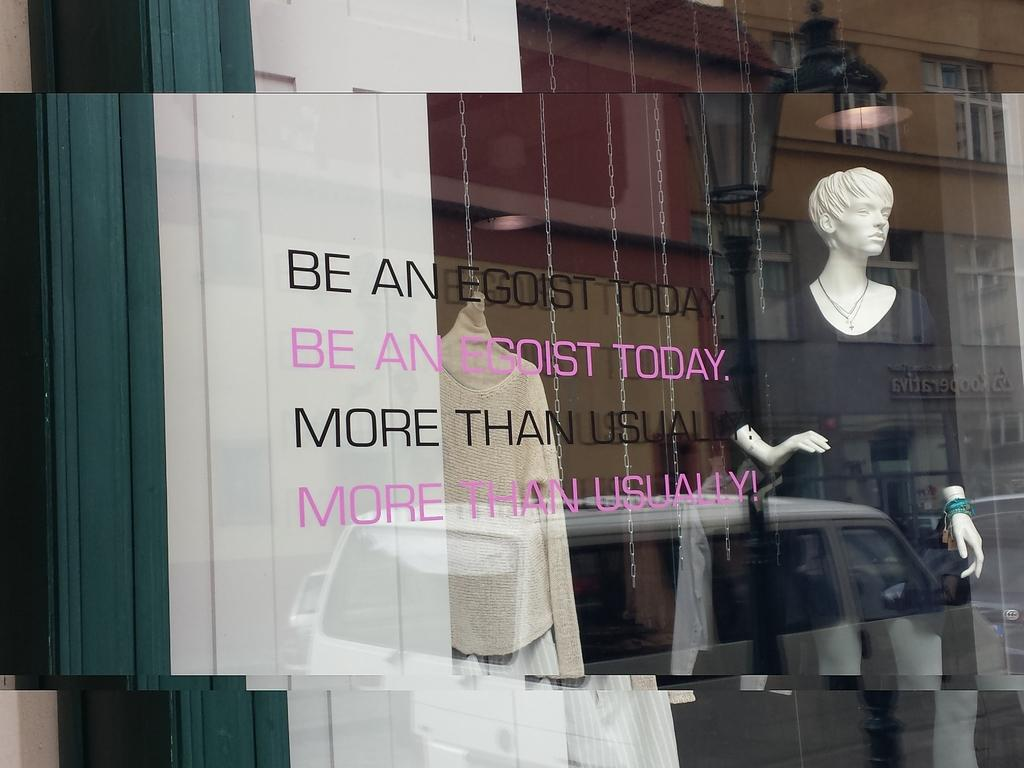What type of objects can be seen in the image? There are mannequins in the image. What else can be seen in the image besides the mannequins? There are reflections of buildings, light poles, and vehicles visible in the image. Where are these reflections visible? These reflections are visible on the glass. Is there any text on the glass? Yes, there is some text on the glass. How many spiders are crawling on the mannequins in the image? There are no spiders visible on the mannequins in the image. What type of knife is being used by the mannequins in the image? There are no knives present in the image; it only features mannequins, reflections, and text on the glass. 